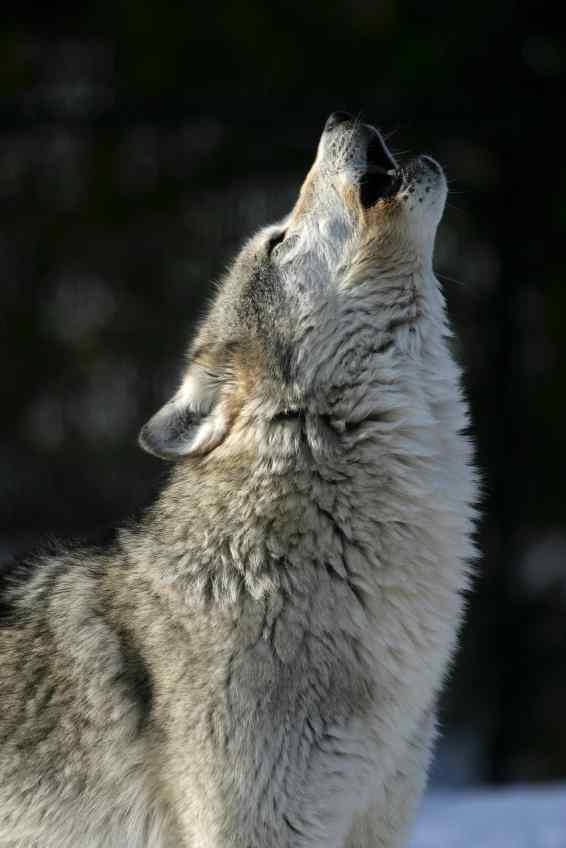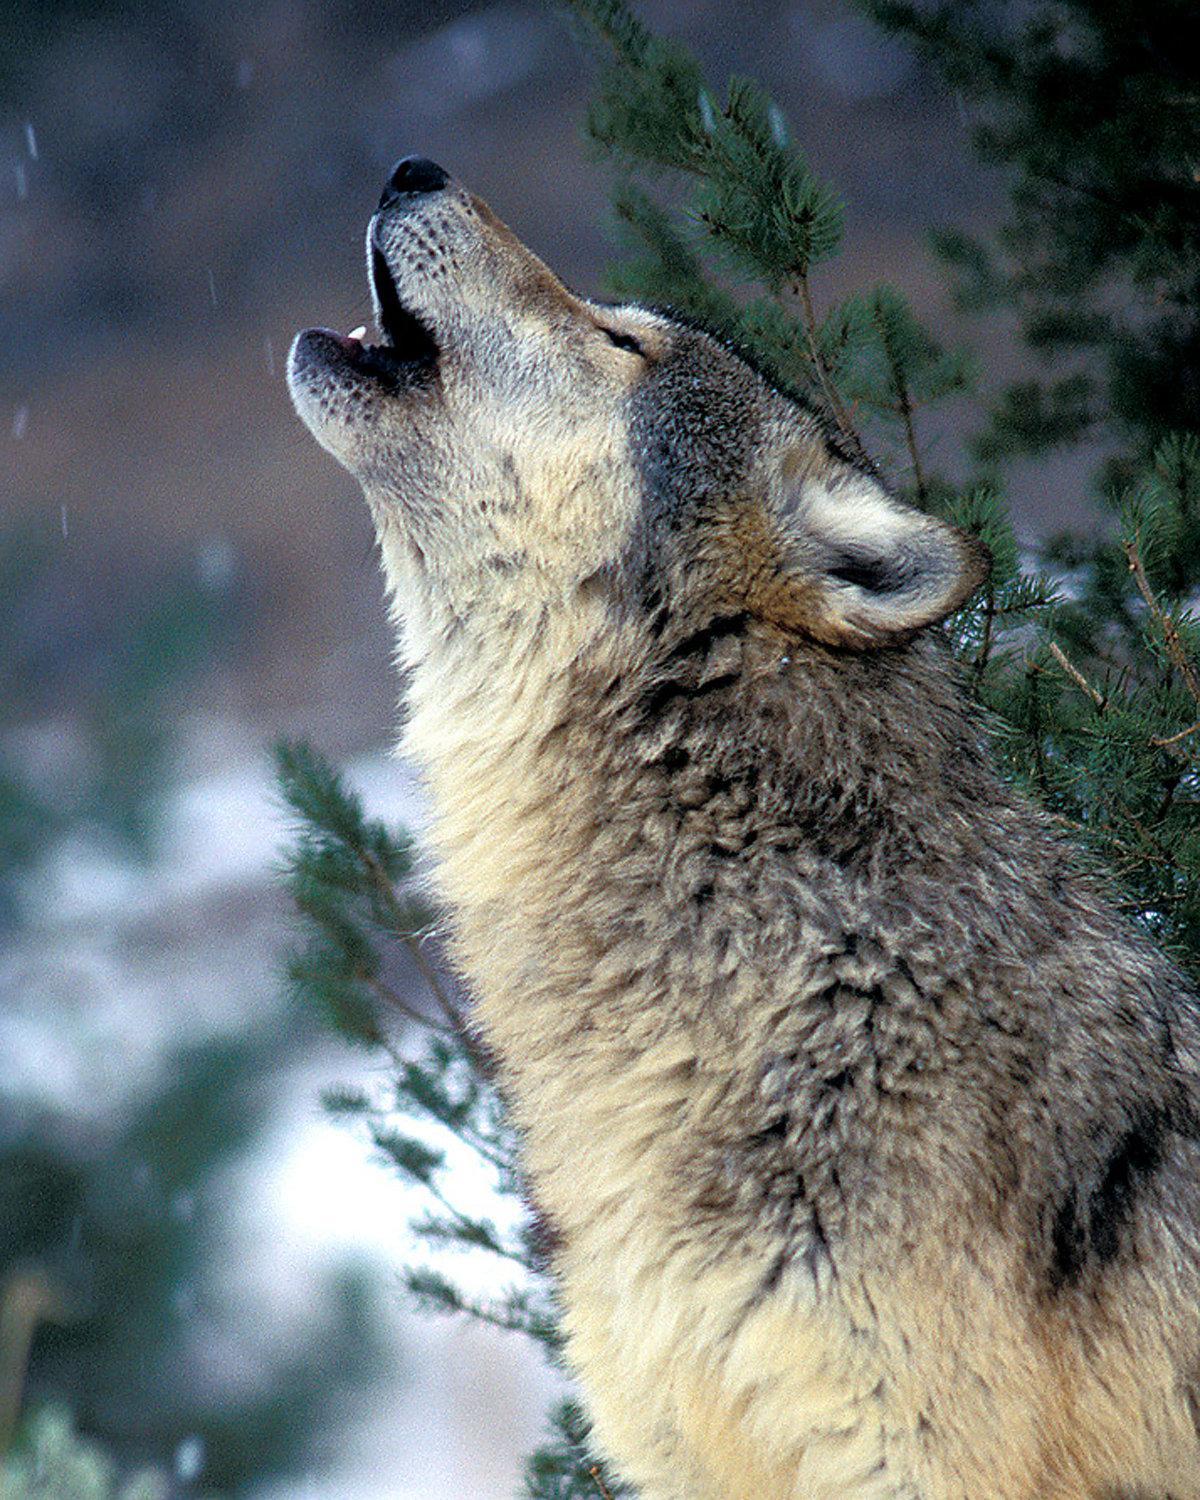The first image is the image on the left, the second image is the image on the right. For the images displayed, is the sentence "There are only two dogs and both are howling at the sky." factually correct? Answer yes or no. Yes. The first image is the image on the left, the second image is the image on the right. Analyze the images presented: Is the assertion "There are exactly two wolves howling in the snow." valid? Answer yes or no. Yes. 